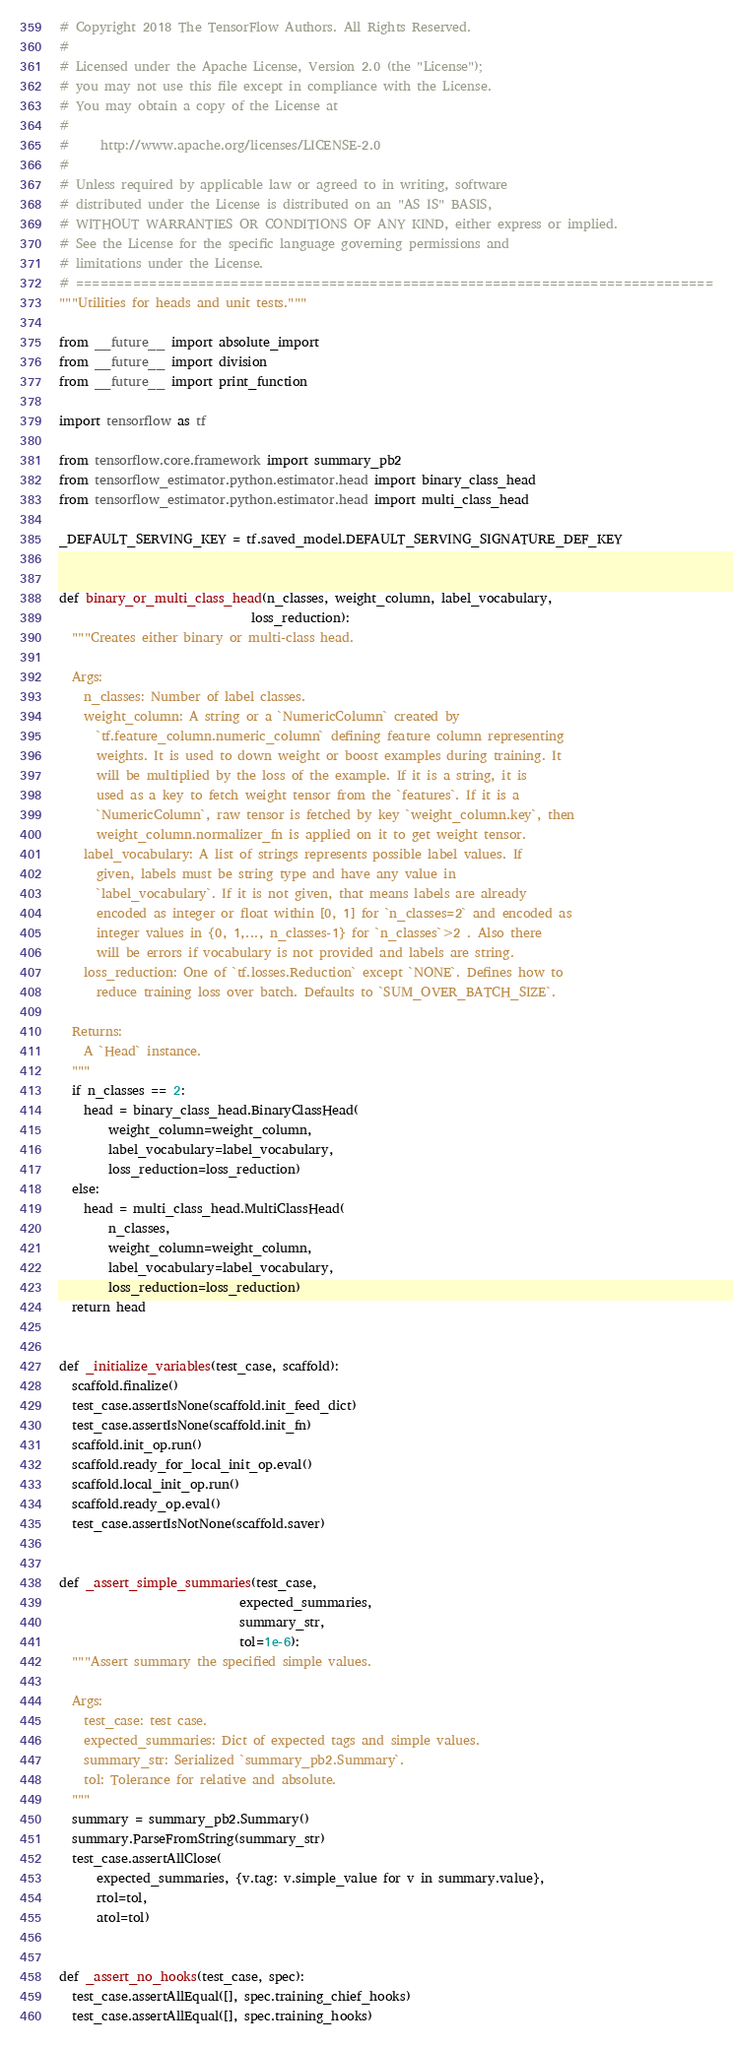Convert code to text. <code><loc_0><loc_0><loc_500><loc_500><_Python_># Copyright 2018 The TensorFlow Authors. All Rights Reserved.
#
# Licensed under the Apache License, Version 2.0 (the "License");
# you may not use this file except in compliance with the License.
# You may obtain a copy of the License at
#
#     http://www.apache.org/licenses/LICENSE-2.0
#
# Unless required by applicable law or agreed to in writing, software
# distributed under the License is distributed on an "AS IS" BASIS,
# WITHOUT WARRANTIES OR CONDITIONS OF ANY KIND, either express or implied.
# See the License for the specific language governing permissions and
# limitations under the License.
# ==============================================================================
"""Utilities for heads and unit tests."""

from __future__ import absolute_import
from __future__ import division
from __future__ import print_function

import tensorflow as tf

from tensorflow.core.framework import summary_pb2
from tensorflow_estimator.python.estimator.head import binary_class_head
from tensorflow_estimator.python.estimator.head import multi_class_head

_DEFAULT_SERVING_KEY = tf.saved_model.DEFAULT_SERVING_SIGNATURE_DEF_KEY


def binary_or_multi_class_head(n_classes, weight_column, label_vocabulary,
                               loss_reduction):
  """Creates either binary or multi-class head.

  Args:
    n_classes: Number of label classes.
    weight_column: A string or a `NumericColumn` created by
      `tf.feature_column.numeric_column` defining feature column representing
      weights. It is used to down weight or boost examples during training. It
      will be multiplied by the loss of the example. If it is a string, it is
      used as a key to fetch weight tensor from the `features`. If it is a
      `NumericColumn`, raw tensor is fetched by key `weight_column.key`, then
      weight_column.normalizer_fn is applied on it to get weight tensor.
    label_vocabulary: A list of strings represents possible label values. If
      given, labels must be string type and have any value in
      `label_vocabulary`. If it is not given, that means labels are already
      encoded as integer or float within [0, 1] for `n_classes=2` and encoded as
      integer values in {0, 1,..., n_classes-1} for `n_classes`>2 . Also there
      will be errors if vocabulary is not provided and labels are string.
    loss_reduction: One of `tf.losses.Reduction` except `NONE`. Defines how to
      reduce training loss over batch. Defaults to `SUM_OVER_BATCH_SIZE`.

  Returns:
    A `Head` instance.
  """
  if n_classes == 2:
    head = binary_class_head.BinaryClassHead(
        weight_column=weight_column,
        label_vocabulary=label_vocabulary,
        loss_reduction=loss_reduction)
  else:
    head = multi_class_head.MultiClassHead(
        n_classes,
        weight_column=weight_column,
        label_vocabulary=label_vocabulary,
        loss_reduction=loss_reduction)
  return head


def _initialize_variables(test_case, scaffold):
  scaffold.finalize()
  test_case.assertIsNone(scaffold.init_feed_dict)
  test_case.assertIsNone(scaffold.init_fn)
  scaffold.init_op.run()
  scaffold.ready_for_local_init_op.eval()
  scaffold.local_init_op.run()
  scaffold.ready_op.eval()
  test_case.assertIsNotNone(scaffold.saver)


def _assert_simple_summaries(test_case,
                             expected_summaries,
                             summary_str,
                             tol=1e-6):
  """Assert summary the specified simple values.

  Args:
    test_case: test case.
    expected_summaries: Dict of expected tags and simple values.
    summary_str: Serialized `summary_pb2.Summary`.
    tol: Tolerance for relative and absolute.
  """
  summary = summary_pb2.Summary()
  summary.ParseFromString(summary_str)
  test_case.assertAllClose(
      expected_summaries, {v.tag: v.simple_value for v in summary.value},
      rtol=tol,
      atol=tol)


def _assert_no_hooks(test_case, spec):
  test_case.assertAllEqual([], spec.training_chief_hooks)
  test_case.assertAllEqual([], spec.training_hooks)
</code> 